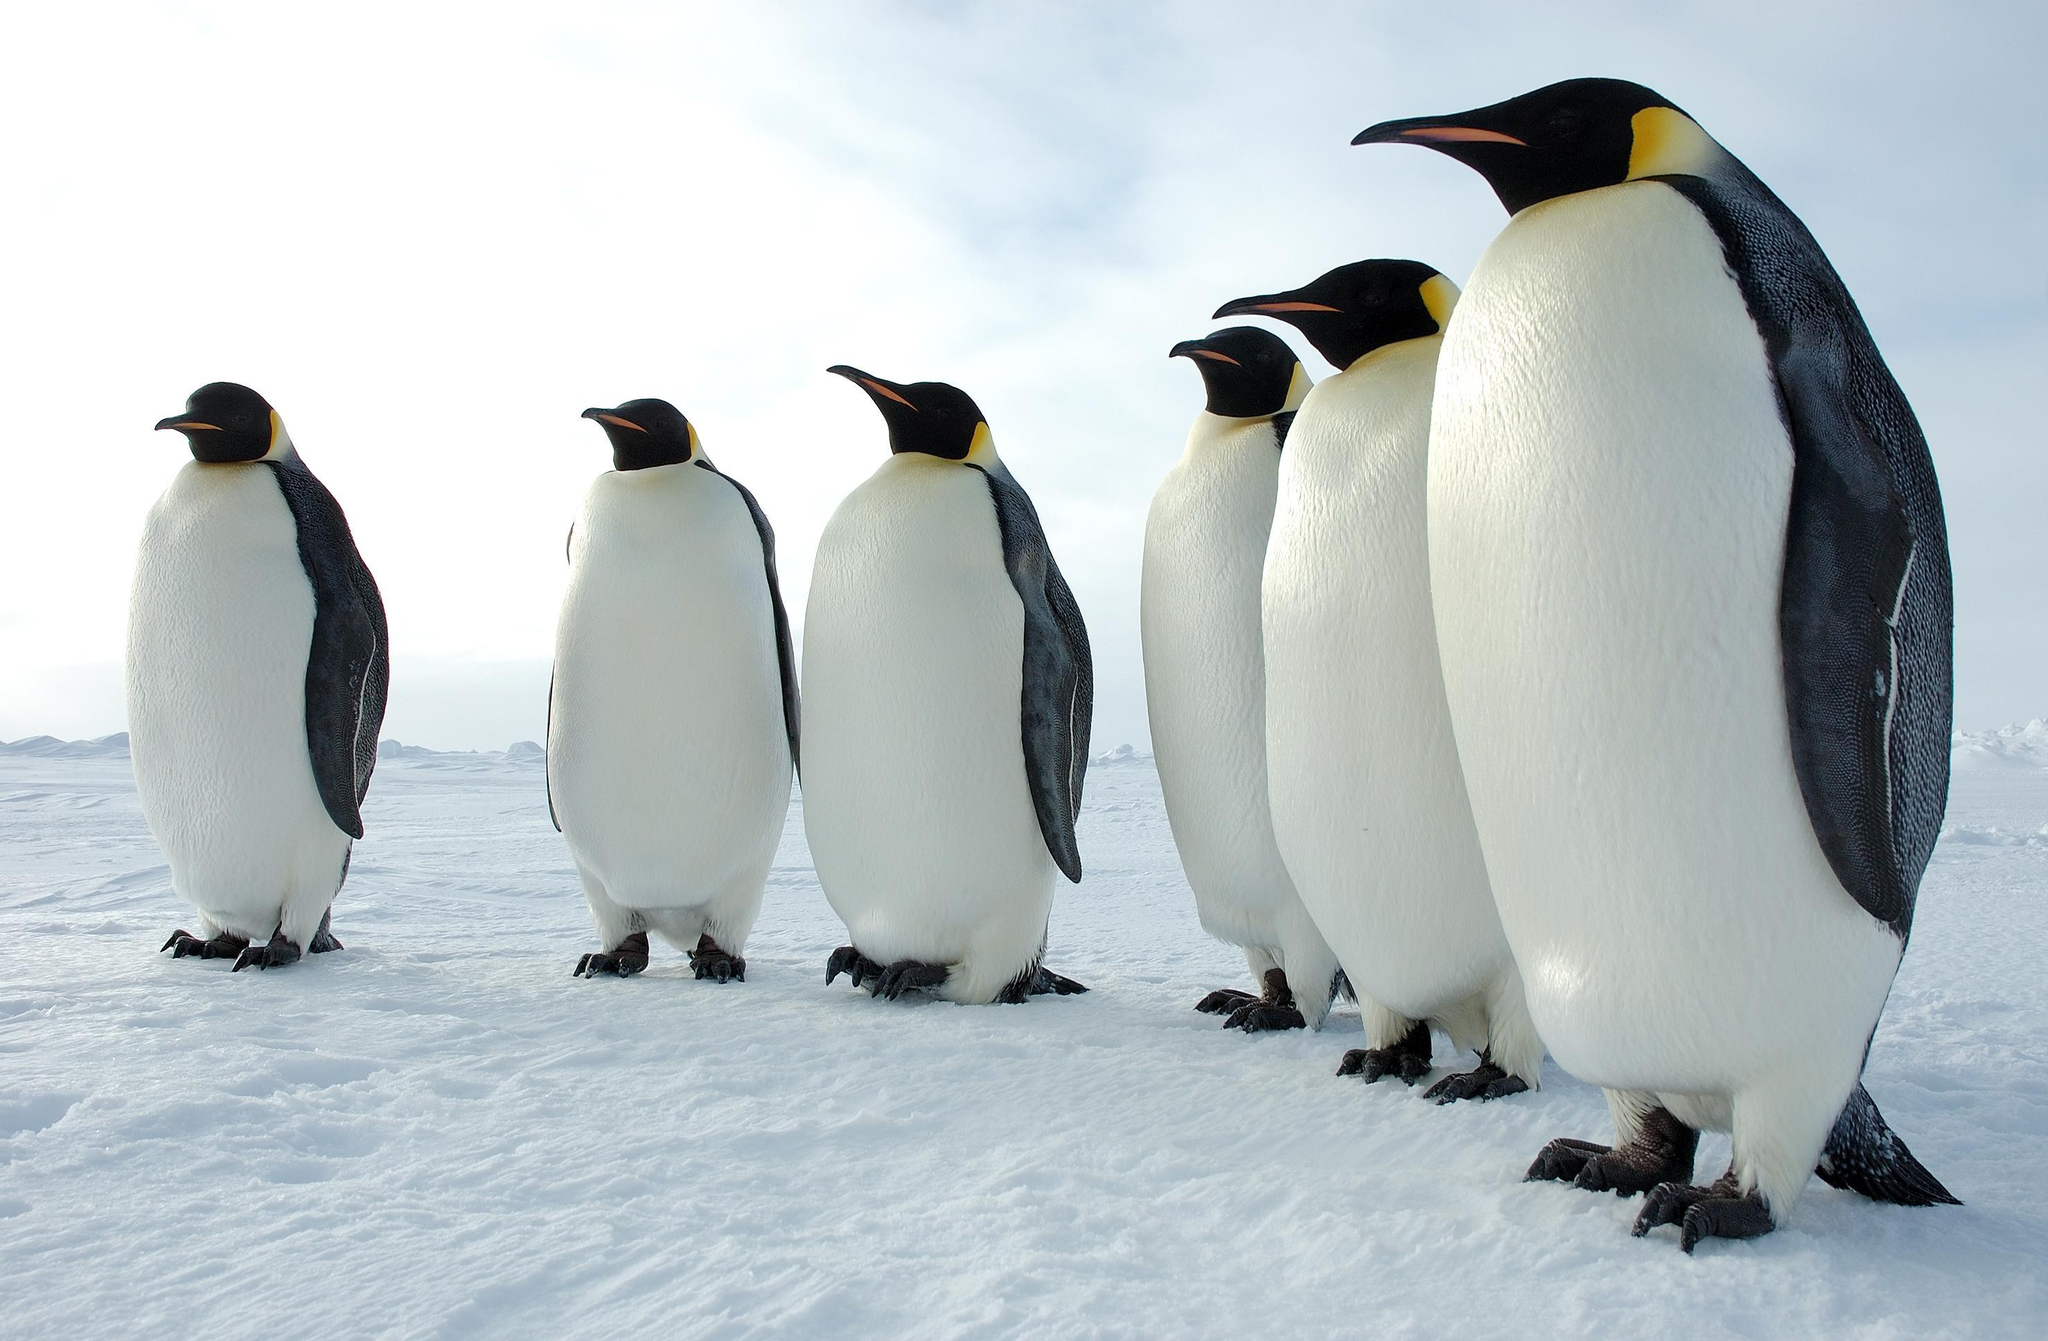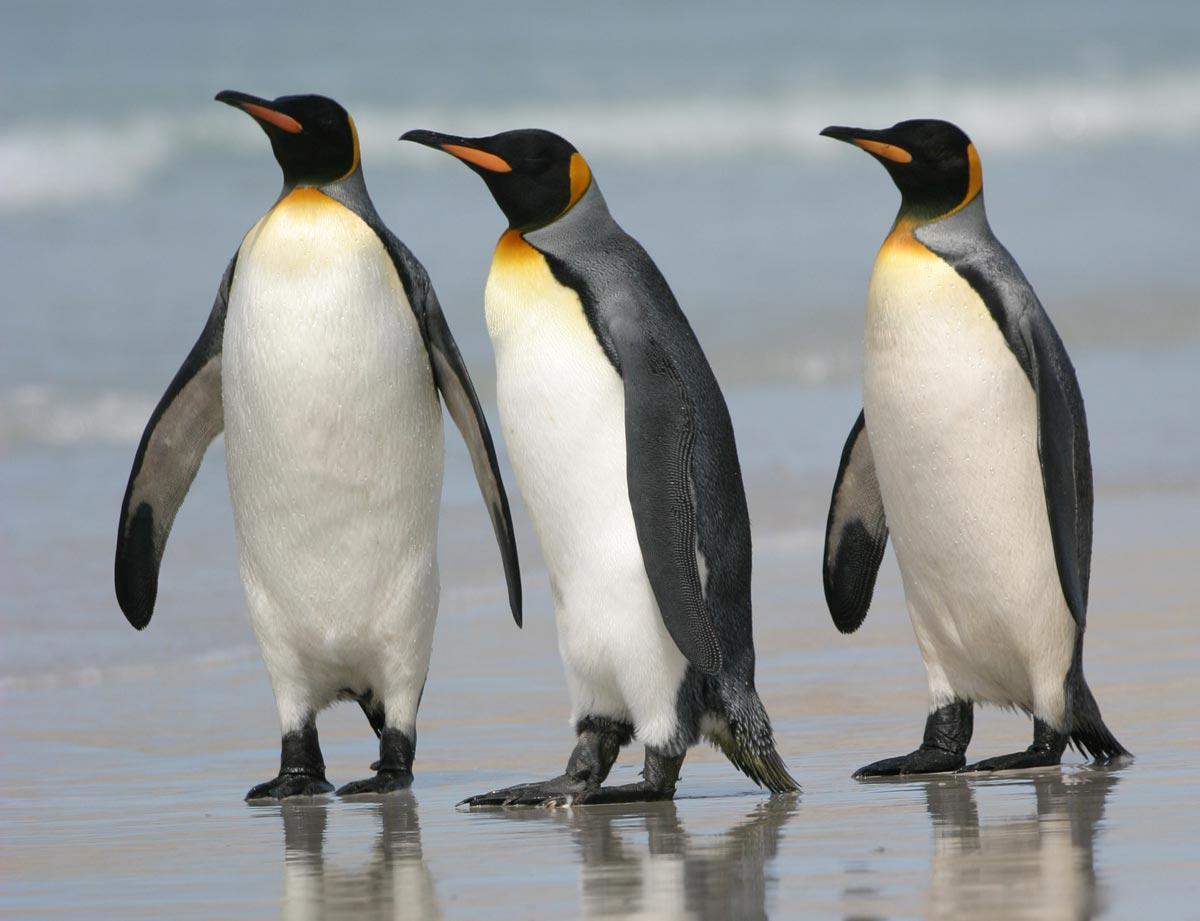The first image is the image on the left, the second image is the image on the right. Evaluate the accuracy of this statement regarding the images: "In one of the images, all penguins are facing right.". Is it true? Answer yes or no. No. The first image is the image on the left, the second image is the image on the right. For the images displayed, is the sentence "One image shows a single adult penguin, standing on snow and facing left." factually correct? Answer yes or no. No. 